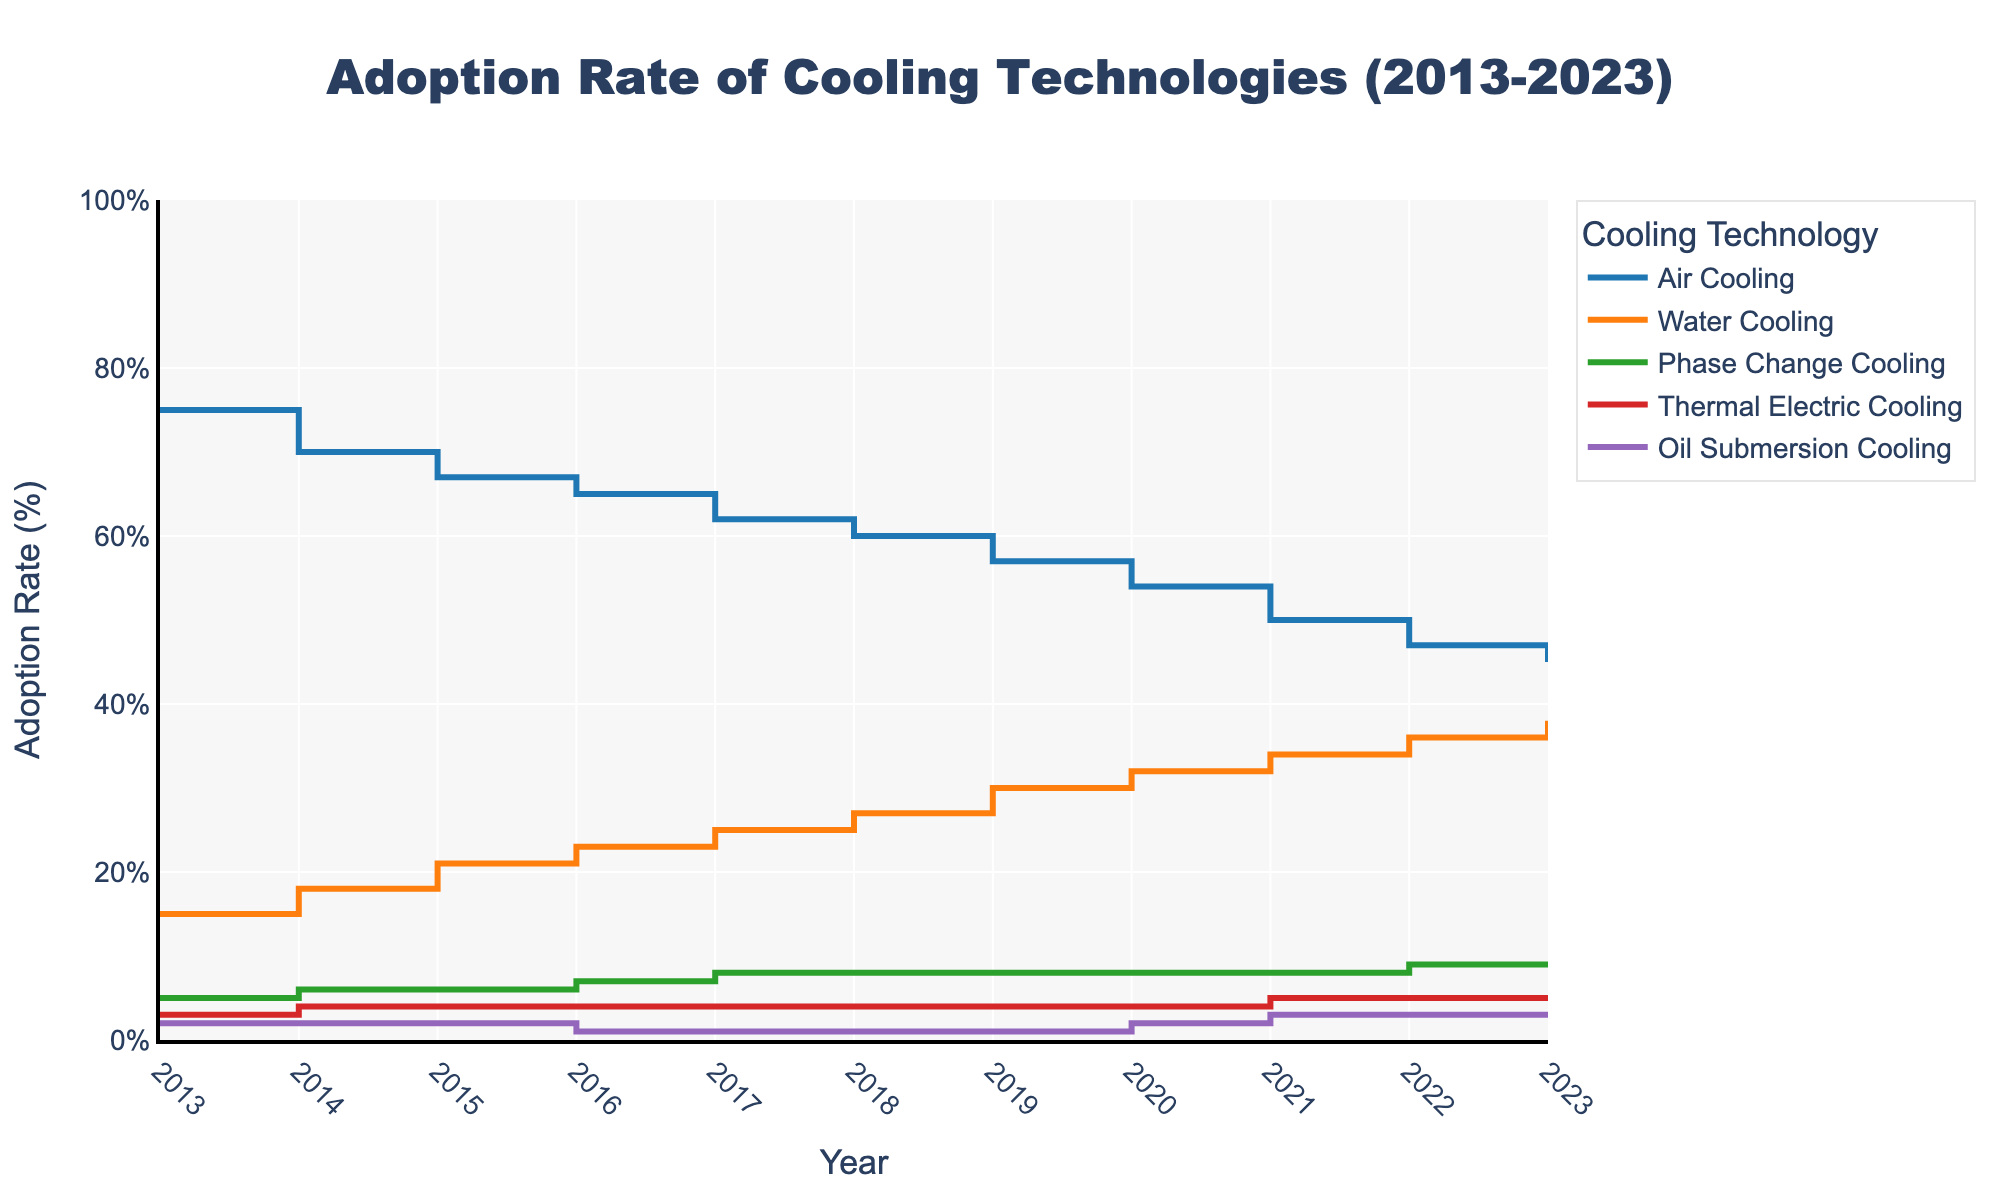What is the title of the figure? The title can be found at the top of the figure. It is a text label that describes the main purpose of the plot. In this case, we see "Adoption Rate of Cooling Technologies (2013-2023)" written on top of the figure.
Answer: Adoption Rate of Cooling Technologies (2013-2023) What does the y-axis represent? The y-axis is labeled with the title "Adoption Rate (%)" and it measures the percentage of adoption for each cooling technology across the years.
Answer: Adoption Rate (%) Which technology had the highest adoption rate in 2013? By looking at the year 2013 on the x-axis and observing the corresponding y-values for all technologies, the highest y-value is for Air Cooling which is at 75%.
Answer: Air Cooling How did the adoption rate of Water Cooling change from 2013 to 2023? By comparing the y-values for Water Cooling in 2013 (15%) and 2023 (38%), we can see that the adoption rate increased over the decade.
Answer: It increased from 15% to 38% Which technology had a decrease in its adoption rate, if any, over the decade? By observing the trend lines for each technology across the years, we see that the adoption rate for Air Cooling decreased from 75% in 2013 to 45% in 2023.
Answer: Air Cooling What is the combined adoption rate of Phase Change Cooling and Oil Submersion Cooling in 2023? The adoption rates for Phase Change Cooling and Oil Submersion Cooling in 2023 are 9% and 3% respectively. Adding them together gives 9% + 3% = 12%.
Answer: 12% Which two technologies had the closest adoption rates in 2023? By looking at the y-values for all technologies in 2023, the adoption rates for Water Cooling (38%) and Phase Change Cooling (9%) are visibly distinct. However, Thermal Electric Cooling and Oil Submersion Cooling both have an adoption rate of 5% and 3% respectively, making them the closest in value.
Answer: Thermal Electric Cooling and Oil Submersion Cooling In which year did Thermal Electric Cooling see the first increase in its adoption rate? By following the trend line for Thermal Electric Cooling, the adoption rate first shows an increase from 3% in 2013 to 4% in 2014.
Answer: 2014 What was the average adoption rate of Oil Submersion Cooling over the decade (2013-2023)? The adoption rates for Oil Submersion Cooling over the years are 2, 2, 2, 1, 1, 1, 1, 2, 3, 3, 3. Summing these values gives 21 and dividing by the number of years (11) gives approximately 1.91%.
Answer: 1.91% 